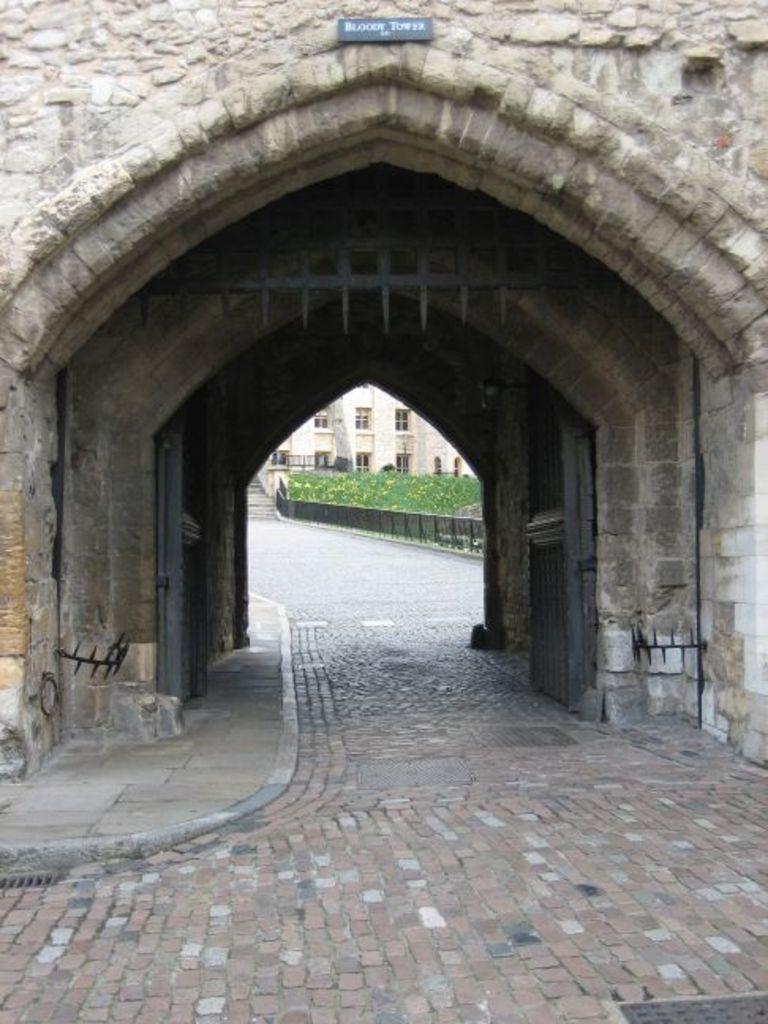How would you summarize this image in a sentence or two? In this picture, we see a London Tower on which "Bloody Tower" is written on it. Beside that, we see an iron railing and plants. Beside that, we see the staircase and beside the staircase, we see a building which is white in color. 